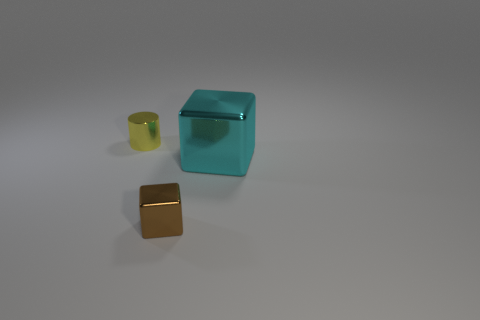Add 1 small brown blocks. How many objects exist? 4 Subtract all blocks. How many objects are left? 1 Subtract 0 cyan spheres. How many objects are left? 3 Subtract all small blue cylinders. Subtract all large objects. How many objects are left? 2 Add 1 tiny metal things. How many tiny metal things are left? 3 Add 1 large cyan metallic objects. How many large cyan metallic objects exist? 2 